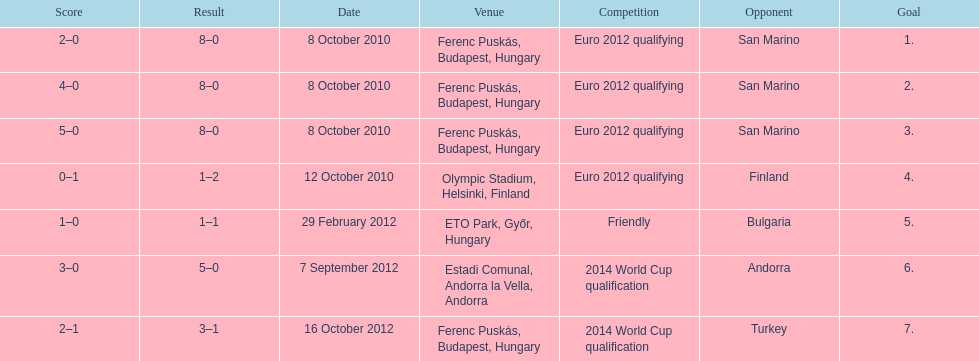In what year did ádám szalai make his next international goal after 2010? 2012. 